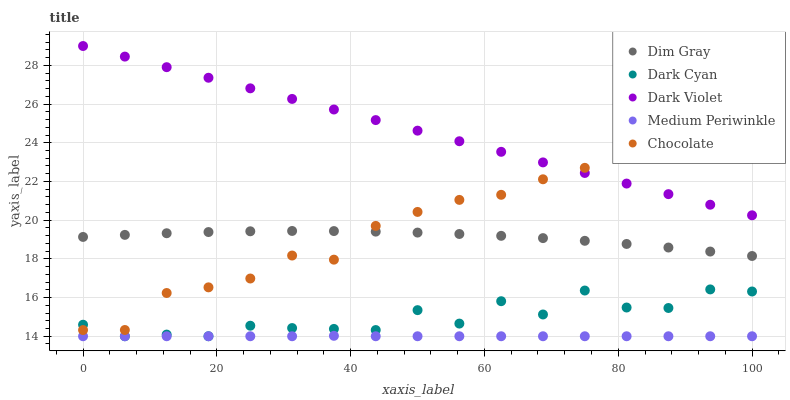Does Medium Periwinkle have the minimum area under the curve?
Answer yes or no. Yes. Does Dark Violet have the maximum area under the curve?
Answer yes or no. Yes. Does Dim Gray have the minimum area under the curve?
Answer yes or no. No. Does Dim Gray have the maximum area under the curve?
Answer yes or no. No. Is Dark Violet the smoothest?
Answer yes or no. Yes. Is Dark Cyan the roughest?
Answer yes or no. Yes. Is Dim Gray the smoothest?
Answer yes or no. No. Is Dim Gray the roughest?
Answer yes or no. No. Does Dark Cyan have the lowest value?
Answer yes or no. Yes. Does Dim Gray have the lowest value?
Answer yes or no. No. Does Dark Violet have the highest value?
Answer yes or no. Yes. Does Dim Gray have the highest value?
Answer yes or no. No. Is Dim Gray less than Dark Violet?
Answer yes or no. Yes. Is Dark Violet greater than Dark Cyan?
Answer yes or no. Yes. Does Dark Cyan intersect Chocolate?
Answer yes or no. Yes. Is Dark Cyan less than Chocolate?
Answer yes or no. No. Is Dark Cyan greater than Chocolate?
Answer yes or no. No. Does Dim Gray intersect Dark Violet?
Answer yes or no. No. 